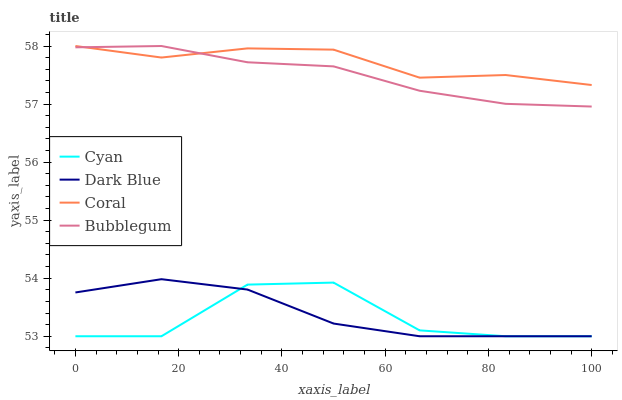Does Cyan have the minimum area under the curve?
Answer yes or no. Yes. Does Coral have the maximum area under the curve?
Answer yes or no. Yes. Does Bubblegum have the minimum area under the curve?
Answer yes or no. No. Does Bubblegum have the maximum area under the curve?
Answer yes or no. No. Is Bubblegum the smoothest?
Answer yes or no. Yes. Is Cyan the roughest?
Answer yes or no. Yes. Is Coral the smoothest?
Answer yes or no. No. Is Coral the roughest?
Answer yes or no. No. Does Cyan have the lowest value?
Answer yes or no. Yes. Does Bubblegum have the lowest value?
Answer yes or no. No. Does Bubblegum have the highest value?
Answer yes or no. Yes. Does Dark Blue have the highest value?
Answer yes or no. No. Is Dark Blue less than Bubblegum?
Answer yes or no. Yes. Is Coral greater than Cyan?
Answer yes or no. Yes. Does Cyan intersect Dark Blue?
Answer yes or no. Yes. Is Cyan less than Dark Blue?
Answer yes or no. No. Is Cyan greater than Dark Blue?
Answer yes or no. No. Does Dark Blue intersect Bubblegum?
Answer yes or no. No. 